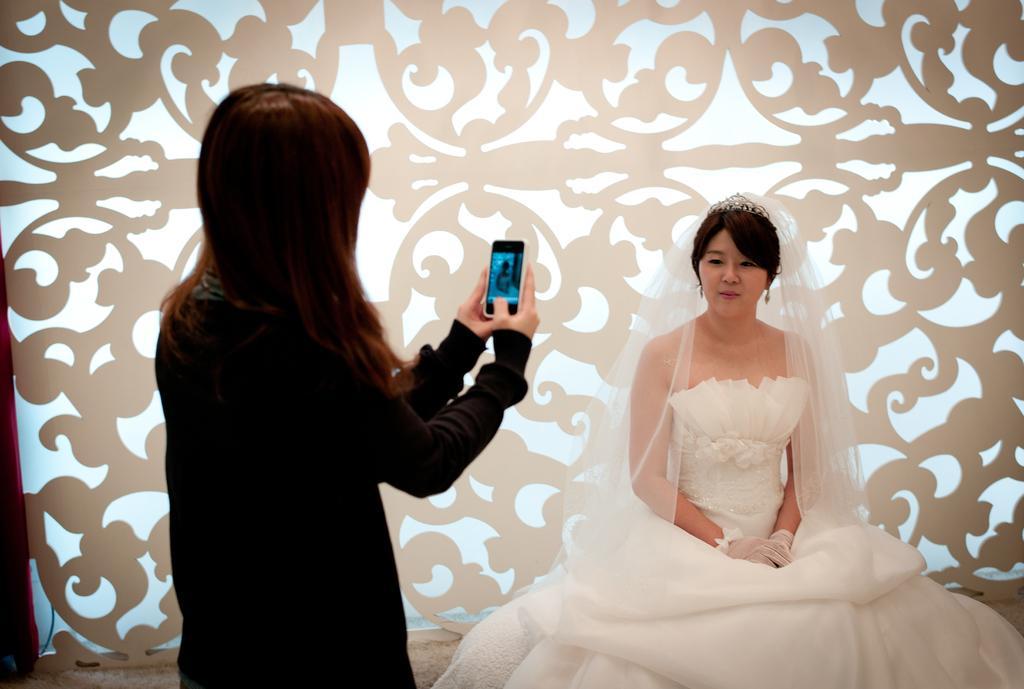In one or two sentences, can you explain what this image depicts? This image consist of two women. To the left, the woman wearing black dress is a holding a phone and capturing image. To the right, the woman is sitting and wearing a white color dress. In the background, there is a structured wall. 